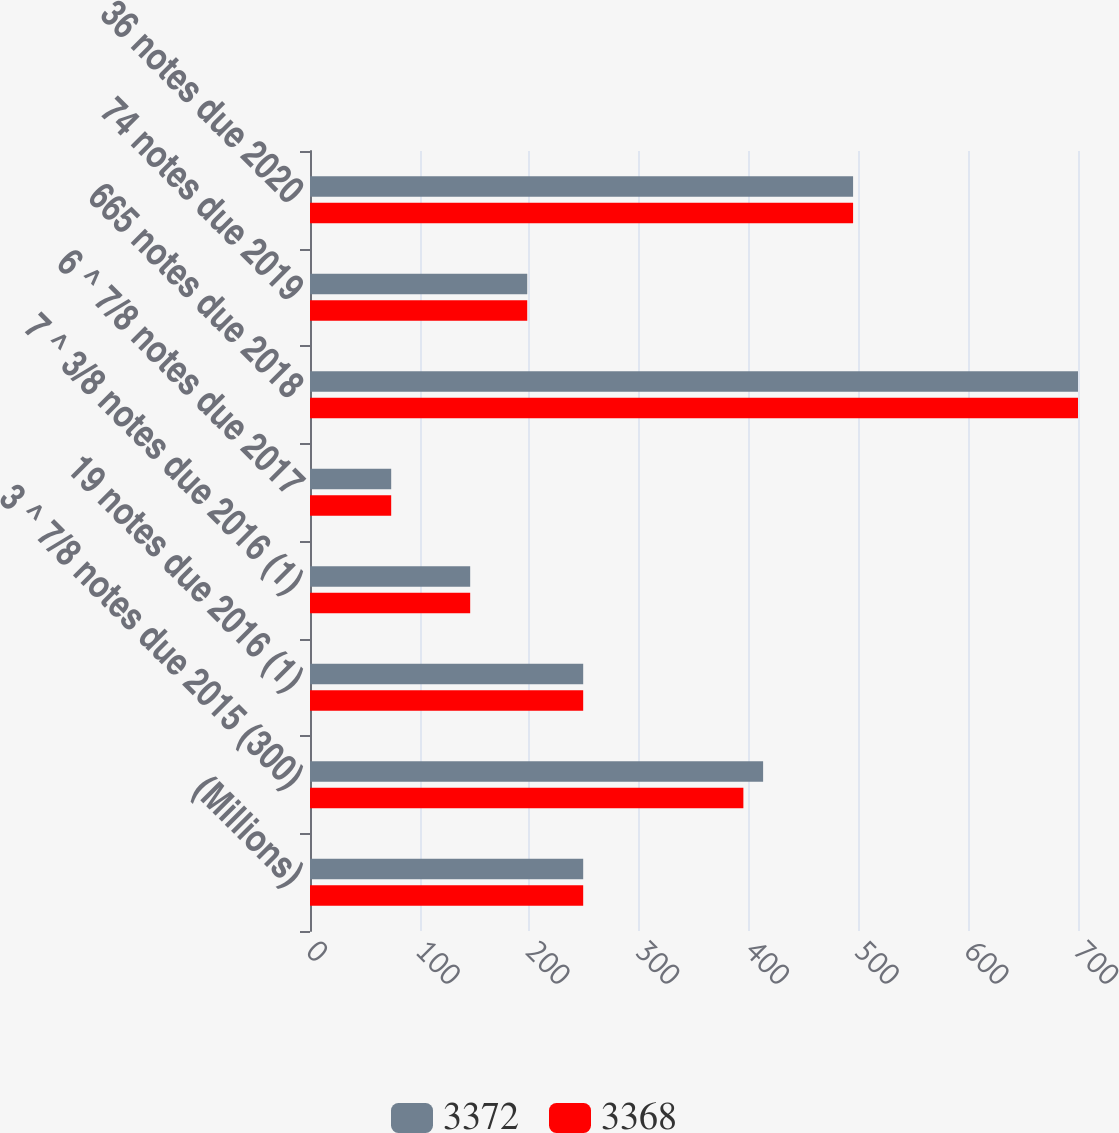Convert chart to OTSL. <chart><loc_0><loc_0><loc_500><loc_500><stacked_bar_chart><ecel><fcel>(Millions)<fcel>3 ^ 7/8 notes due 2015 (300)<fcel>19 notes due 2016 (1)<fcel>7 ^ 3/8 notes due 2016 (1)<fcel>6 ^ 7/8 notes due 2017<fcel>665 notes due 2018<fcel>74 notes due 2019<fcel>36 notes due 2020<nl><fcel>3372<fcel>249<fcel>413<fcel>249<fcel>146<fcel>74<fcel>700<fcel>198<fcel>495<nl><fcel>3368<fcel>249<fcel>395<fcel>249<fcel>146<fcel>74<fcel>700<fcel>198<fcel>495<nl></chart> 